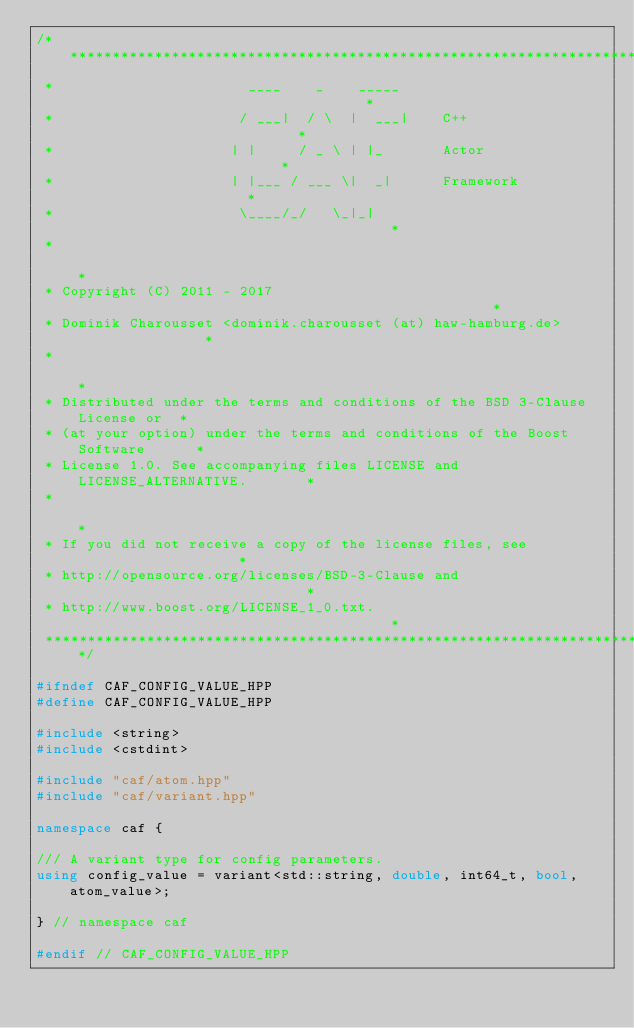<code> <loc_0><loc_0><loc_500><loc_500><_C++_>/******************************************************************************
 *                       ____    _    _____                                   *
 *                      / ___|  / \  |  ___|    C++                           *
 *                     | |     / _ \ | |_       Actor                         *
 *                     | |___ / ___ \|  _|      Framework                     *
 *                      \____/_/   \_|_|                                      *
 *                                                                            *
 * Copyright (C) 2011 - 2017                                                  *
 * Dominik Charousset <dominik.charousset (at) haw-hamburg.de>                *
 *                                                                            *
 * Distributed under the terms and conditions of the BSD 3-Clause License or  *
 * (at your option) under the terms and conditions of the Boost Software      *
 * License 1.0. See accompanying files LICENSE and LICENSE_ALTERNATIVE.       *
 *                                                                            *
 * If you did not receive a copy of the license files, see                    *
 * http://opensource.org/licenses/BSD-3-Clause and                            *
 * http://www.boost.org/LICENSE_1_0.txt.                                      *
 ******************************************************************************/

#ifndef CAF_CONFIG_VALUE_HPP
#define CAF_CONFIG_VALUE_HPP

#include <string>
#include <cstdint>

#include "caf/atom.hpp"
#include "caf/variant.hpp"

namespace caf {

/// A variant type for config parameters.
using config_value = variant<std::string, double, int64_t, bool, atom_value>;

} // namespace caf

#endif // CAF_CONFIG_VALUE_HPP
</code> 